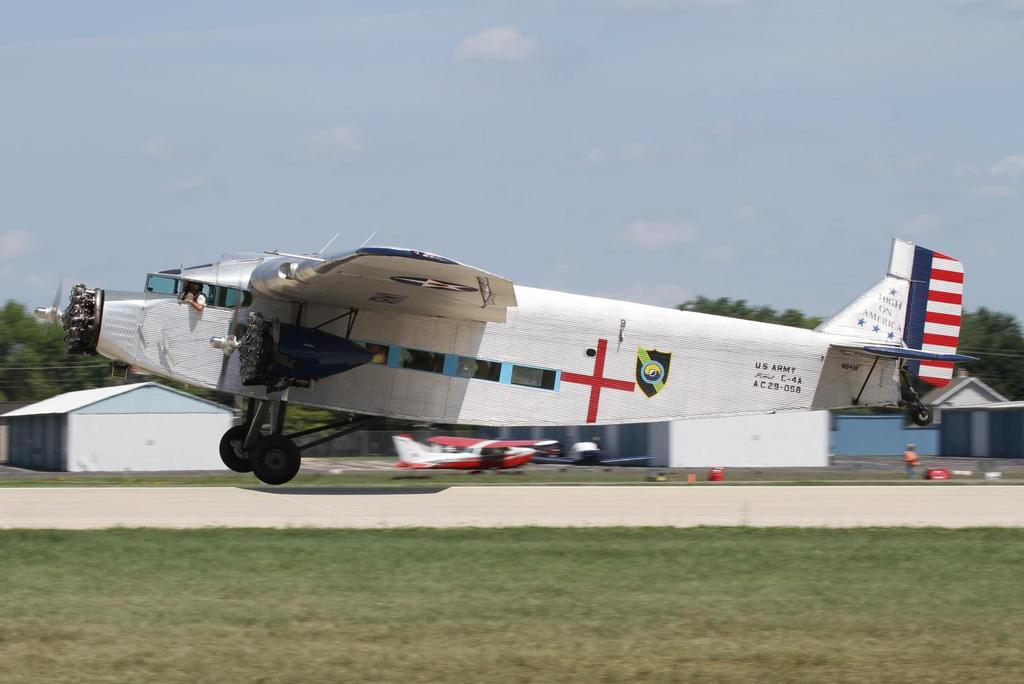<image>
Summarize the visual content of the image. a US Army High on America C-4A A C 29-058 with a red cross on it. 